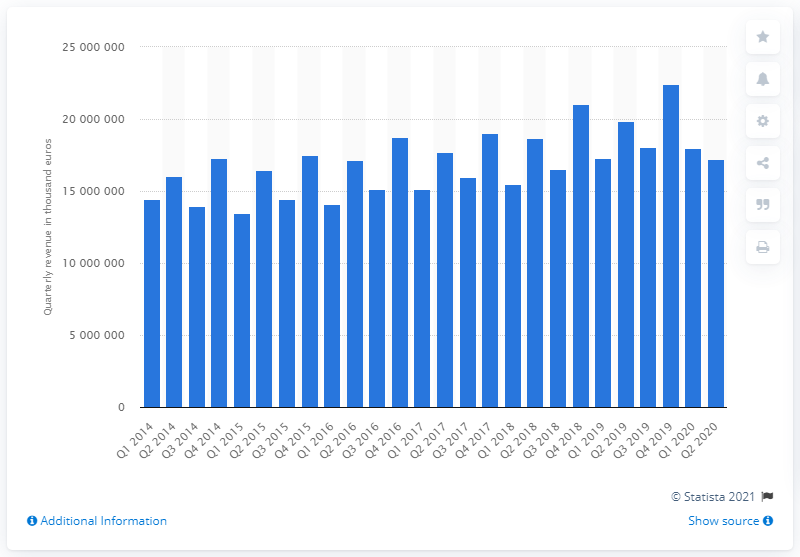Point out several critical features in this image. In the second quarter of 2015, the revenue of the construction industry was approximately 165,596,350. The construction industry generated a revenue of 1,348,882,400 in the first half of 2015. 